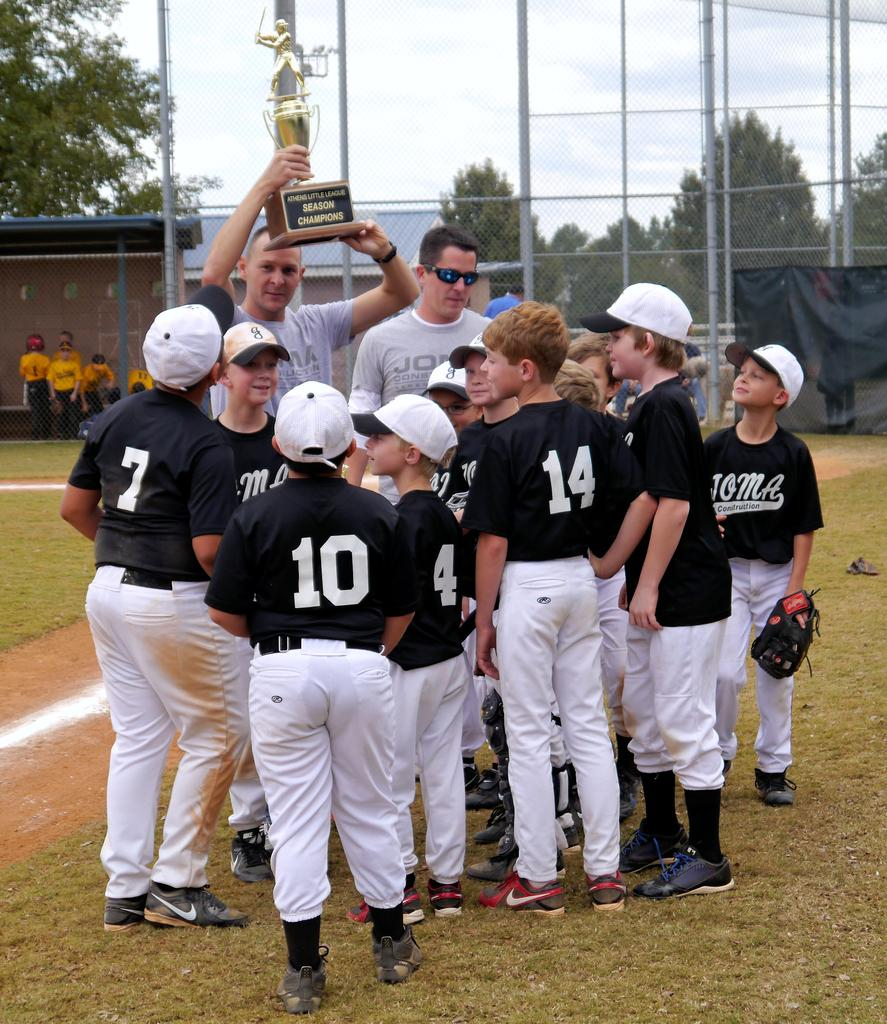<image>
Render a clear and concise summary of the photo. Baseball players celebrate as they are awarded the Athens Little League Seasons Champions trophy. 